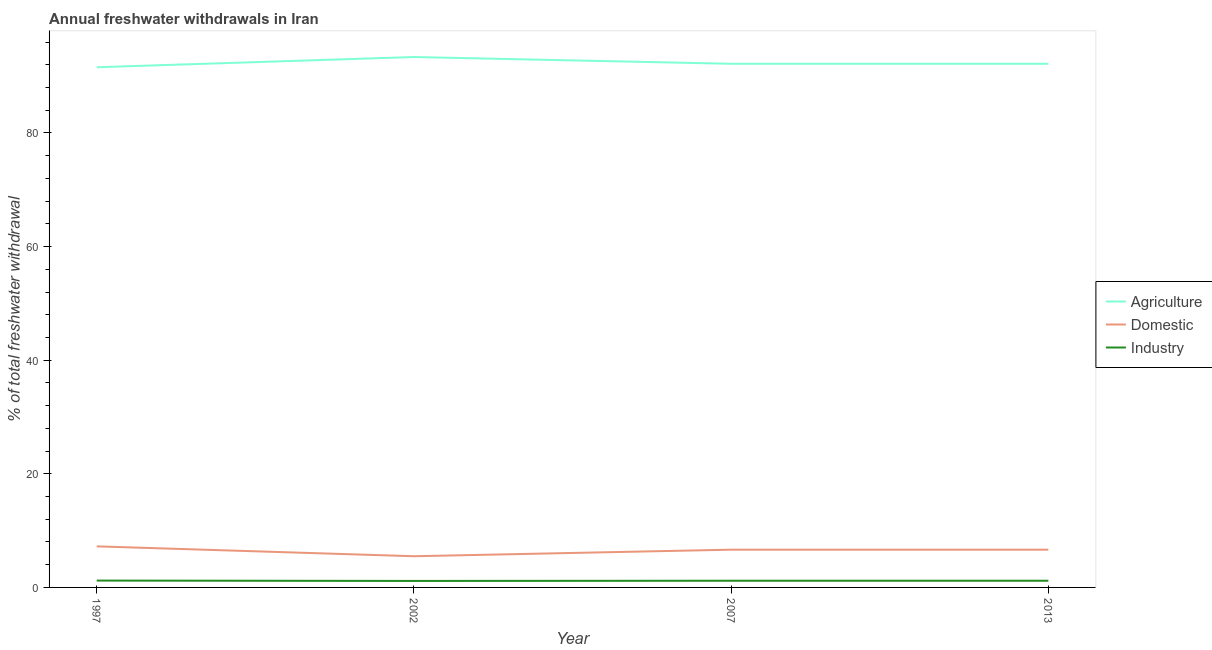How many different coloured lines are there?
Make the answer very short. 3. Does the line corresponding to percentage of freshwater withdrawal for agriculture intersect with the line corresponding to percentage of freshwater withdrawal for industry?
Ensure brevity in your answer.  No. Is the number of lines equal to the number of legend labels?
Offer a terse response. Yes. What is the percentage of freshwater withdrawal for industry in 2013?
Give a very brief answer. 1.18. Across all years, what is the maximum percentage of freshwater withdrawal for industry?
Make the answer very short. 1.21. Across all years, what is the minimum percentage of freshwater withdrawal for agriculture?
Your answer should be very brief. 91.57. In which year was the percentage of freshwater withdrawal for industry minimum?
Offer a terse response. 2002. What is the total percentage of freshwater withdrawal for industry in the graph?
Give a very brief answer. 4.71. What is the difference between the percentage of freshwater withdrawal for agriculture in 2013 and the percentage of freshwater withdrawal for industry in 1997?
Offer a terse response. 90.98. What is the average percentage of freshwater withdrawal for industry per year?
Ensure brevity in your answer.  1.18. In the year 2007, what is the difference between the percentage of freshwater withdrawal for agriculture and percentage of freshwater withdrawal for domestic purposes?
Give a very brief answer. 85.54. In how many years, is the percentage of freshwater withdrawal for industry greater than 84 %?
Your answer should be compact. 0. What is the ratio of the percentage of freshwater withdrawal for agriculture in 1997 to that in 2007?
Offer a terse response. 0.99. Is the percentage of freshwater withdrawal for agriculture in 1997 less than that in 2002?
Your answer should be compact. Yes. What is the difference between the highest and the second highest percentage of freshwater withdrawal for agriculture?
Provide a short and direct response. 1.19. What is the difference between the highest and the lowest percentage of freshwater withdrawal for industry?
Your answer should be very brief. 0.06. In how many years, is the percentage of freshwater withdrawal for industry greater than the average percentage of freshwater withdrawal for industry taken over all years?
Offer a terse response. 3. What is the difference between two consecutive major ticks on the Y-axis?
Keep it short and to the point. 20. Does the graph contain grids?
Ensure brevity in your answer.  No. How are the legend labels stacked?
Keep it short and to the point. Vertical. What is the title of the graph?
Provide a short and direct response. Annual freshwater withdrawals in Iran. Does "Agricultural raw materials" appear as one of the legend labels in the graph?
Ensure brevity in your answer.  No. What is the label or title of the Y-axis?
Provide a short and direct response. % of total freshwater withdrawal. What is the % of total freshwater withdrawal in Agriculture in 1997?
Offer a very short reply. 91.57. What is the % of total freshwater withdrawal in Domestic in 1997?
Your response must be concise. 7.23. What is the % of total freshwater withdrawal in Industry in 1997?
Ensure brevity in your answer.  1.21. What is the % of total freshwater withdrawal of Agriculture in 2002?
Offer a terse response. 93.37. What is the % of total freshwater withdrawal in Domestic in 2002?
Your answer should be compact. 5.49. What is the % of total freshwater withdrawal in Industry in 2002?
Provide a short and direct response. 1.14. What is the % of total freshwater withdrawal in Agriculture in 2007?
Offer a very short reply. 92.18. What is the % of total freshwater withdrawal in Domestic in 2007?
Your answer should be compact. 6.64. What is the % of total freshwater withdrawal of Industry in 2007?
Provide a succinct answer. 1.18. What is the % of total freshwater withdrawal of Agriculture in 2013?
Offer a terse response. 92.18. What is the % of total freshwater withdrawal of Domestic in 2013?
Offer a terse response. 6.64. What is the % of total freshwater withdrawal in Industry in 2013?
Make the answer very short. 1.18. Across all years, what is the maximum % of total freshwater withdrawal of Agriculture?
Offer a terse response. 93.37. Across all years, what is the maximum % of total freshwater withdrawal of Domestic?
Make the answer very short. 7.23. Across all years, what is the maximum % of total freshwater withdrawal of Industry?
Offer a terse response. 1.21. Across all years, what is the minimum % of total freshwater withdrawal in Agriculture?
Provide a succinct answer. 91.57. Across all years, what is the minimum % of total freshwater withdrawal in Domestic?
Provide a succinct answer. 5.49. Across all years, what is the minimum % of total freshwater withdrawal of Industry?
Offer a very short reply. 1.14. What is the total % of total freshwater withdrawal in Agriculture in the graph?
Offer a very short reply. 369.3. What is the total % of total freshwater withdrawal in Domestic in the graph?
Provide a succinct answer. 26.01. What is the total % of total freshwater withdrawal in Industry in the graph?
Provide a short and direct response. 4.71. What is the difference between the % of total freshwater withdrawal in Agriculture in 1997 and that in 2002?
Keep it short and to the point. -1.8. What is the difference between the % of total freshwater withdrawal of Domestic in 1997 and that in 2002?
Make the answer very short. 1.74. What is the difference between the % of total freshwater withdrawal in Industry in 1997 and that in 2002?
Your response must be concise. 0.06. What is the difference between the % of total freshwater withdrawal in Agriculture in 1997 and that in 2007?
Offer a terse response. -0.61. What is the difference between the % of total freshwater withdrawal of Domestic in 1997 and that in 2007?
Your response must be concise. 0.58. What is the difference between the % of total freshwater withdrawal in Industry in 1997 and that in 2007?
Provide a succinct answer. 0.03. What is the difference between the % of total freshwater withdrawal in Agriculture in 1997 and that in 2013?
Ensure brevity in your answer.  -0.61. What is the difference between the % of total freshwater withdrawal of Domestic in 1997 and that in 2013?
Offer a terse response. 0.58. What is the difference between the % of total freshwater withdrawal of Industry in 1997 and that in 2013?
Your answer should be very brief. 0.03. What is the difference between the % of total freshwater withdrawal of Agriculture in 2002 and that in 2007?
Your answer should be very brief. 1.19. What is the difference between the % of total freshwater withdrawal in Domestic in 2002 and that in 2007?
Offer a very short reply. -1.15. What is the difference between the % of total freshwater withdrawal in Industry in 2002 and that in 2007?
Offer a terse response. -0.04. What is the difference between the % of total freshwater withdrawal in Agriculture in 2002 and that in 2013?
Your response must be concise. 1.19. What is the difference between the % of total freshwater withdrawal of Domestic in 2002 and that in 2013?
Your answer should be compact. -1.15. What is the difference between the % of total freshwater withdrawal of Industry in 2002 and that in 2013?
Provide a succinct answer. -0.04. What is the difference between the % of total freshwater withdrawal in Agriculture in 1997 and the % of total freshwater withdrawal in Domestic in 2002?
Give a very brief answer. 86.08. What is the difference between the % of total freshwater withdrawal of Agriculture in 1997 and the % of total freshwater withdrawal of Industry in 2002?
Your answer should be very brief. 90.43. What is the difference between the % of total freshwater withdrawal in Domestic in 1997 and the % of total freshwater withdrawal in Industry in 2002?
Keep it short and to the point. 6.09. What is the difference between the % of total freshwater withdrawal of Agriculture in 1997 and the % of total freshwater withdrawal of Domestic in 2007?
Offer a terse response. 84.92. What is the difference between the % of total freshwater withdrawal of Agriculture in 1997 and the % of total freshwater withdrawal of Industry in 2007?
Your answer should be compact. 90.39. What is the difference between the % of total freshwater withdrawal of Domestic in 1997 and the % of total freshwater withdrawal of Industry in 2007?
Your answer should be very brief. 6.05. What is the difference between the % of total freshwater withdrawal of Agriculture in 1997 and the % of total freshwater withdrawal of Domestic in 2013?
Provide a short and direct response. 84.92. What is the difference between the % of total freshwater withdrawal in Agriculture in 1997 and the % of total freshwater withdrawal in Industry in 2013?
Keep it short and to the point. 90.39. What is the difference between the % of total freshwater withdrawal in Domestic in 1997 and the % of total freshwater withdrawal in Industry in 2013?
Your answer should be compact. 6.05. What is the difference between the % of total freshwater withdrawal of Agriculture in 2002 and the % of total freshwater withdrawal of Domestic in 2007?
Offer a very short reply. 86.72. What is the difference between the % of total freshwater withdrawal of Agriculture in 2002 and the % of total freshwater withdrawal of Industry in 2007?
Provide a short and direct response. 92.19. What is the difference between the % of total freshwater withdrawal in Domestic in 2002 and the % of total freshwater withdrawal in Industry in 2007?
Offer a very short reply. 4.31. What is the difference between the % of total freshwater withdrawal of Agriculture in 2002 and the % of total freshwater withdrawal of Domestic in 2013?
Ensure brevity in your answer.  86.72. What is the difference between the % of total freshwater withdrawal of Agriculture in 2002 and the % of total freshwater withdrawal of Industry in 2013?
Your answer should be very brief. 92.19. What is the difference between the % of total freshwater withdrawal of Domestic in 2002 and the % of total freshwater withdrawal of Industry in 2013?
Your answer should be compact. 4.31. What is the difference between the % of total freshwater withdrawal of Agriculture in 2007 and the % of total freshwater withdrawal of Domestic in 2013?
Provide a short and direct response. 85.53. What is the difference between the % of total freshwater withdrawal of Agriculture in 2007 and the % of total freshwater withdrawal of Industry in 2013?
Your response must be concise. 91. What is the difference between the % of total freshwater withdrawal in Domestic in 2007 and the % of total freshwater withdrawal in Industry in 2013?
Ensure brevity in your answer.  5.47. What is the average % of total freshwater withdrawal in Agriculture per year?
Ensure brevity in your answer.  92.33. What is the average % of total freshwater withdrawal of Domestic per year?
Provide a short and direct response. 6.5. What is the average % of total freshwater withdrawal of Industry per year?
Your answer should be very brief. 1.18. In the year 1997, what is the difference between the % of total freshwater withdrawal in Agriculture and % of total freshwater withdrawal in Domestic?
Give a very brief answer. 84.34. In the year 1997, what is the difference between the % of total freshwater withdrawal in Agriculture and % of total freshwater withdrawal in Industry?
Your answer should be compact. 90.36. In the year 1997, what is the difference between the % of total freshwater withdrawal in Domestic and % of total freshwater withdrawal in Industry?
Your answer should be very brief. 6.02. In the year 2002, what is the difference between the % of total freshwater withdrawal in Agriculture and % of total freshwater withdrawal in Domestic?
Your response must be concise. 87.88. In the year 2002, what is the difference between the % of total freshwater withdrawal of Agriculture and % of total freshwater withdrawal of Industry?
Ensure brevity in your answer.  92.23. In the year 2002, what is the difference between the % of total freshwater withdrawal of Domestic and % of total freshwater withdrawal of Industry?
Your answer should be very brief. 4.35. In the year 2007, what is the difference between the % of total freshwater withdrawal of Agriculture and % of total freshwater withdrawal of Domestic?
Your answer should be very brief. 85.53. In the year 2007, what is the difference between the % of total freshwater withdrawal of Agriculture and % of total freshwater withdrawal of Industry?
Ensure brevity in your answer.  91. In the year 2007, what is the difference between the % of total freshwater withdrawal of Domestic and % of total freshwater withdrawal of Industry?
Provide a short and direct response. 5.47. In the year 2013, what is the difference between the % of total freshwater withdrawal of Agriculture and % of total freshwater withdrawal of Domestic?
Your answer should be very brief. 85.53. In the year 2013, what is the difference between the % of total freshwater withdrawal of Agriculture and % of total freshwater withdrawal of Industry?
Ensure brevity in your answer.  91. In the year 2013, what is the difference between the % of total freshwater withdrawal of Domestic and % of total freshwater withdrawal of Industry?
Offer a terse response. 5.47. What is the ratio of the % of total freshwater withdrawal of Agriculture in 1997 to that in 2002?
Offer a terse response. 0.98. What is the ratio of the % of total freshwater withdrawal of Domestic in 1997 to that in 2002?
Your answer should be very brief. 1.32. What is the ratio of the % of total freshwater withdrawal in Industry in 1997 to that in 2002?
Ensure brevity in your answer.  1.05. What is the ratio of the % of total freshwater withdrawal in Domestic in 1997 to that in 2007?
Keep it short and to the point. 1.09. What is the ratio of the % of total freshwater withdrawal of Industry in 1997 to that in 2007?
Give a very brief answer. 1.02. What is the ratio of the % of total freshwater withdrawal of Agriculture in 1997 to that in 2013?
Provide a succinct answer. 0.99. What is the ratio of the % of total freshwater withdrawal of Domestic in 1997 to that in 2013?
Your answer should be compact. 1.09. What is the ratio of the % of total freshwater withdrawal of Industry in 1997 to that in 2013?
Ensure brevity in your answer.  1.02. What is the ratio of the % of total freshwater withdrawal of Agriculture in 2002 to that in 2007?
Keep it short and to the point. 1.01. What is the ratio of the % of total freshwater withdrawal in Domestic in 2002 to that in 2007?
Offer a very short reply. 0.83. What is the ratio of the % of total freshwater withdrawal of Industry in 2002 to that in 2007?
Ensure brevity in your answer.  0.97. What is the ratio of the % of total freshwater withdrawal of Agriculture in 2002 to that in 2013?
Your response must be concise. 1.01. What is the ratio of the % of total freshwater withdrawal in Domestic in 2002 to that in 2013?
Ensure brevity in your answer.  0.83. What is the ratio of the % of total freshwater withdrawal of Industry in 2002 to that in 2013?
Make the answer very short. 0.97. What is the ratio of the % of total freshwater withdrawal in Domestic in 2007 to that in 2013?
Your answer should be compact. 1. What is the difference between the highest and the second highest % of total freshwater withdrawal of Agriculture?
Offer a very short reply. 1.19. What is the difference between the highest and the second highest % of total freshwater withdrawal in Domestic?
Provide a succinct answer. 0.58. What is the difference between the highest and the second highest % of total freshwater withdrawal of Industry?
Keep it short and to the point. 0.03. What is the difference between the highest and the lowest % of total freshwater withdrawal of Domestic?
Keep it short and to the point. 1.74. What is the difference between the highest and the lowest % of total freshwater withdrawal in Industry?
Keep it short and to the point. 0.06. 